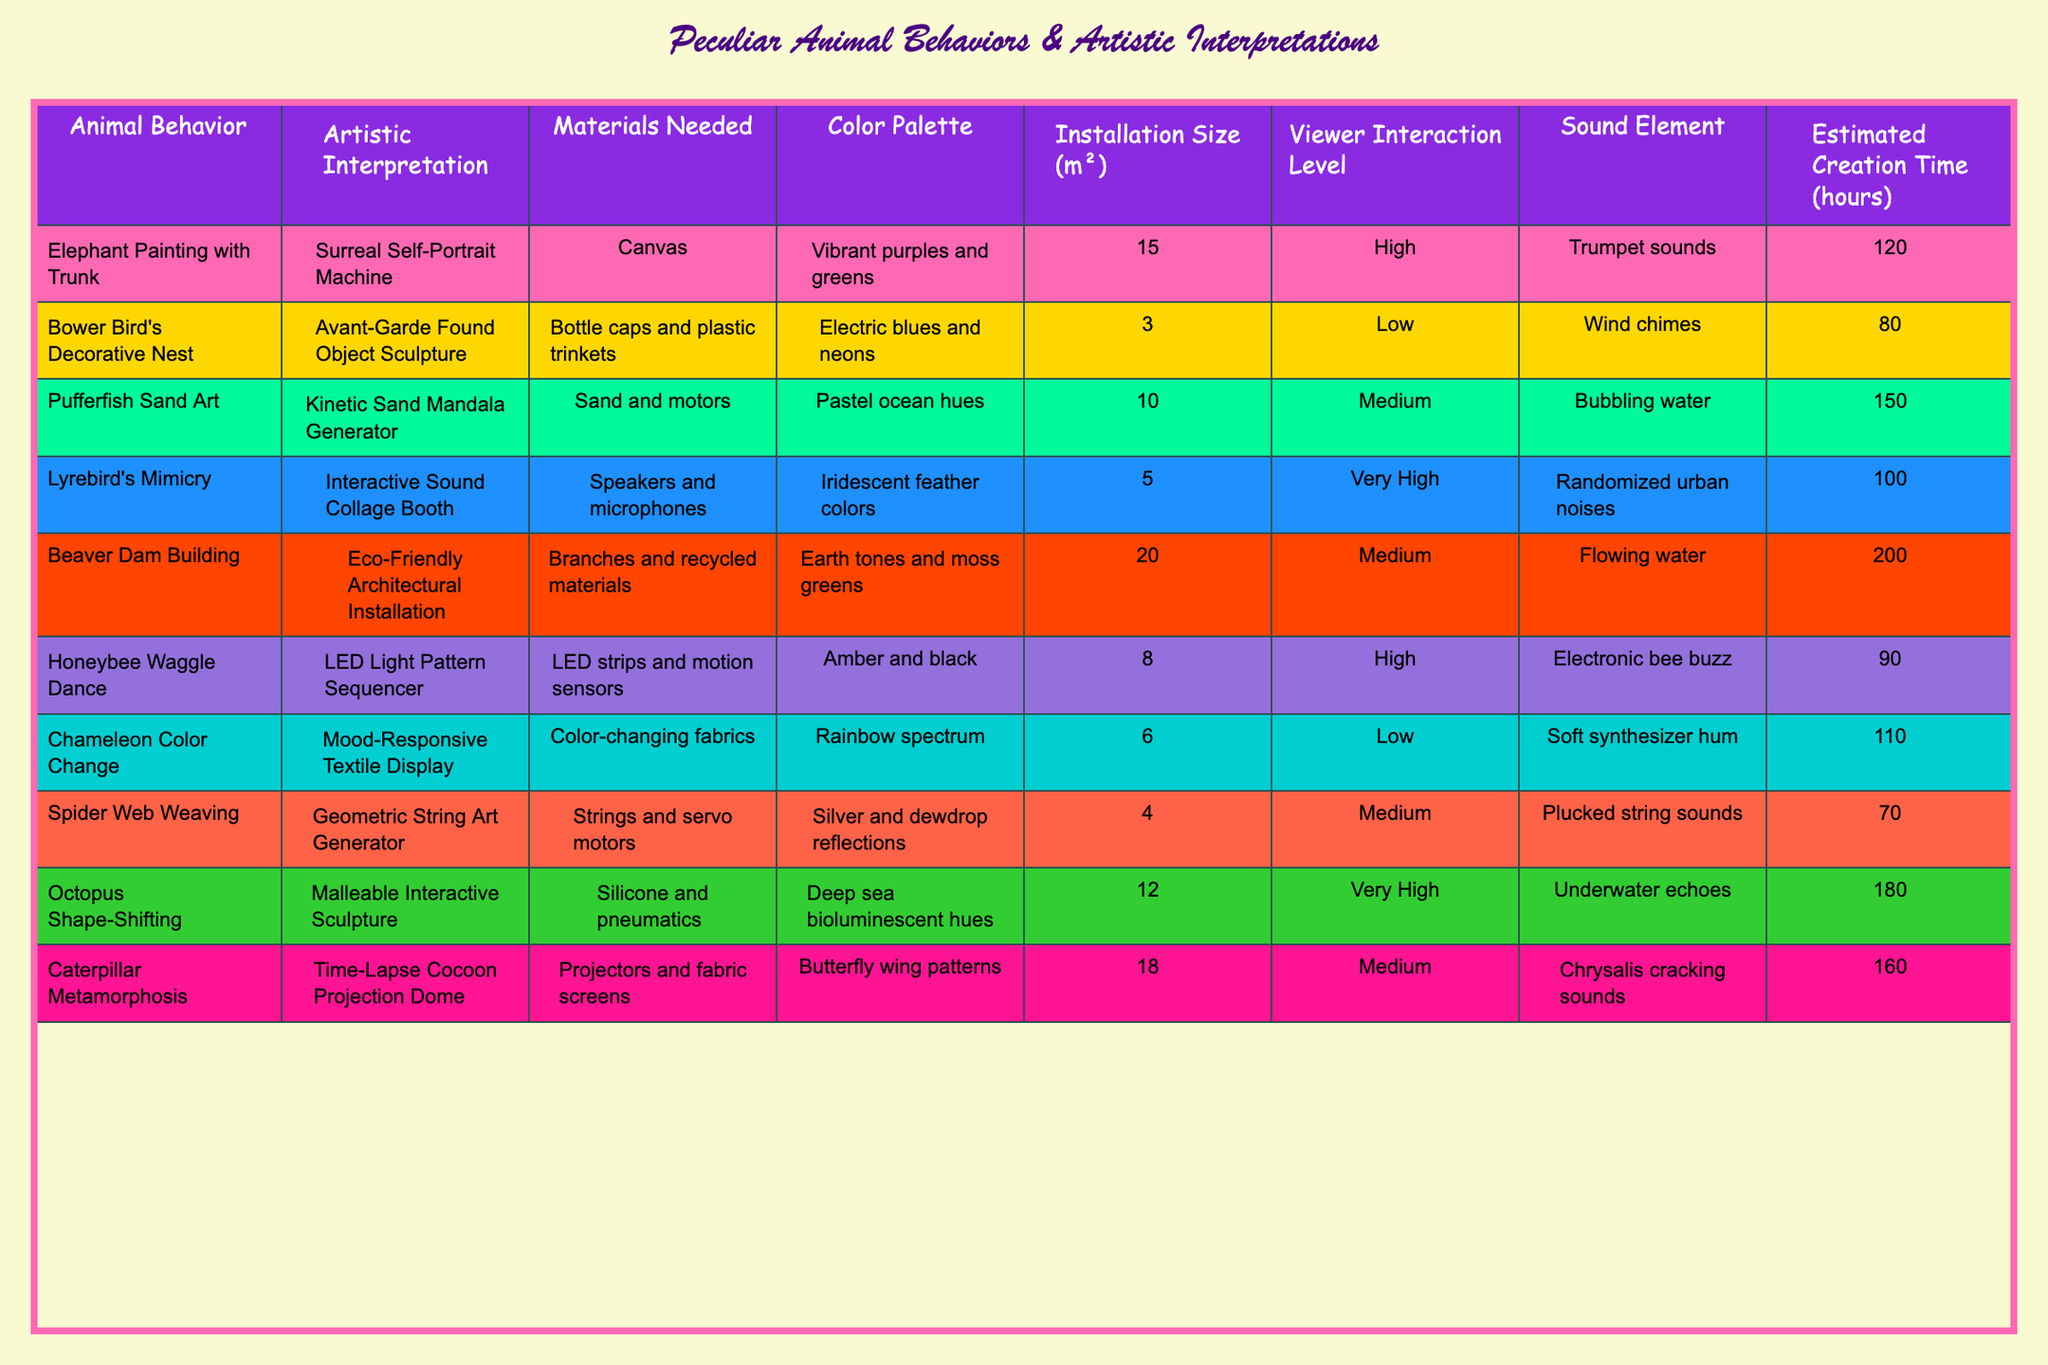What is the artistic interpretation for the Bower Bird's Decorative Nest? According to the table, the artistic interpretation associated with the Bower Bird's behavior is "Avant-Garde Found Object Sculpture."
Answer: Avant-Garde Found Object Sculpture How many materials are needed for the Honeybee Waggle Dance project? The table states that the materials needed for the Honeybee Waggle Dance project are "LED strips and motion sensors," meaning two types of materials are listed.
Answer: 2 Which animal's behavior involves a sound element resembling bubbling water? The table shows that the Pufferfish Sand Art has a sound element described as "Bubbling water."
Answer: Pufferfish Sand Art What is the estimated creation time for the Octopus Shape-Shifting installation? From the table, it's noted that the estimated creation time for the Octopus Shape-Shifting installation is 180 hours.
Answer: 180 hours Which installation has the highest estimated creation time? The table indicates that the Beaver Dam Building has the highest estimated creation time (200 hours) when comparing all installations.
Answer: Beaver Dam Building What is the total installation size of the Caterpillar Metamorphosis and Spider Web Weaving projects? The table lists the installation sizes as 18 m² for Caterpillar Metamorphosis and 4 m² for Spider Web Weaving. Summing these gives 18 + 4 = 22 m² total.
Answer: 22 m² Does the Lyrebird's Mimicry installation require a high level of viewer interaction? According to the data, the Lyrebird's Mimicry installation is categorized with a very high level of viewer interaction.
Answer: Yes What is the common color palette for the artistic interpretations involving insects, specifically the Honeybee and Caterpillar projects? The Honeybee Waggle Dance uses an amber and black palette, and Caterpillar Metamorphosis features butterfly wing patterns, which also often include vibrant colors. The common theme is using bright colors.
Answer: Bright colors How many installations have a low viewer interaction level? From the table, there are two installations listed with low viewer interaction levels: Bower Bird's Decorative Nest and Chameleon Color Change.
Answer: 2 If you combine the installation sizes of the Pufferfish Sand Art and Catapult Metamorphosis, what is the result? The installation size of Pufferfish Sand Art is 10 m², and for Caterpillar Metamorphosis, it's 18 m². Combining these gives 10 + 18 = 28 m² total.
Answer: 28 m² 